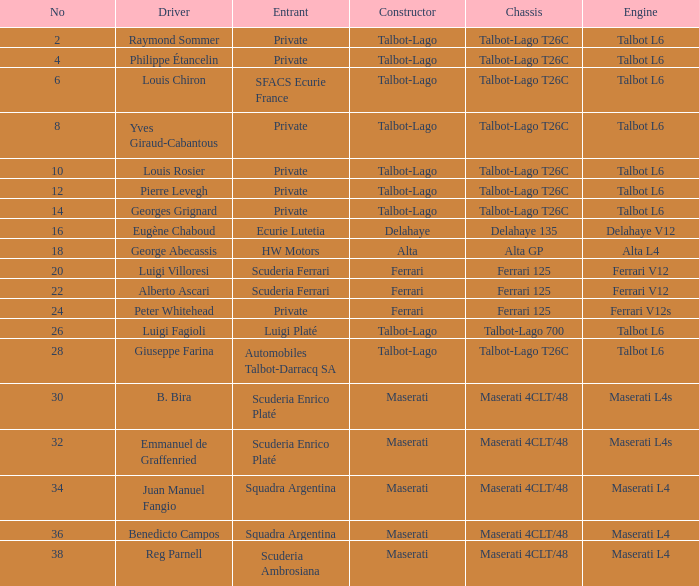Name the chassis for b. bira Maserati 4CLT/48. 